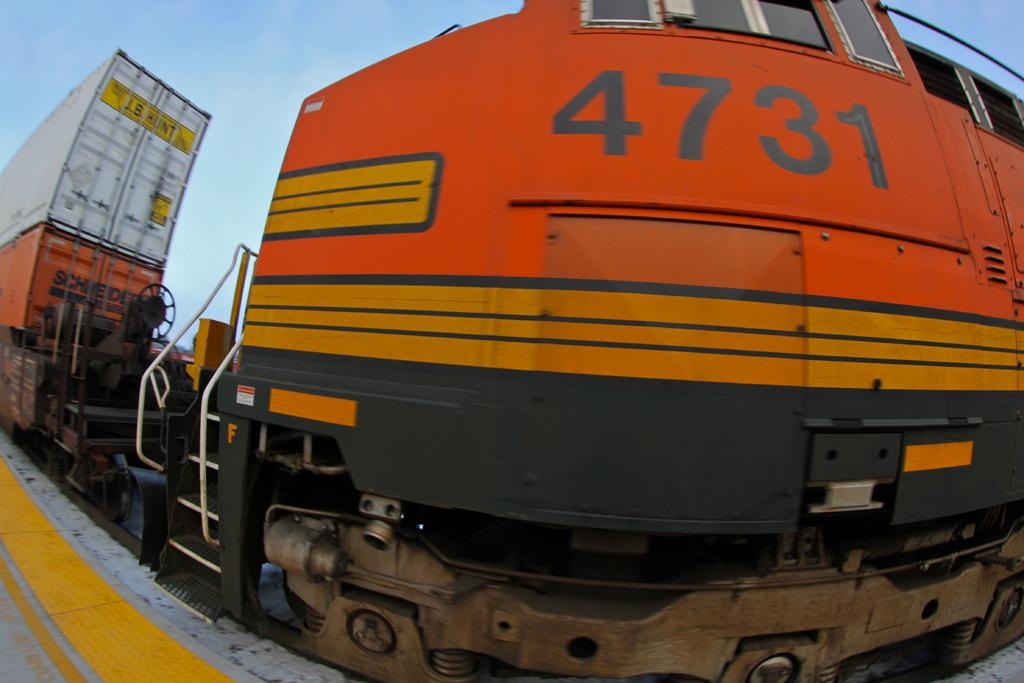What is the main subject of the image? The main subject of the image is a train. Where is the train located in the image? The train is in the front of the image. What additional detail can be observed on the train? There are numbers written on the train. What type of rail can be seen in the image? There is no rail present in the image; it only features a train. What scene is being depicted in the image? The image does not depict a specific scene; it simply shows a train with numbers on it. 